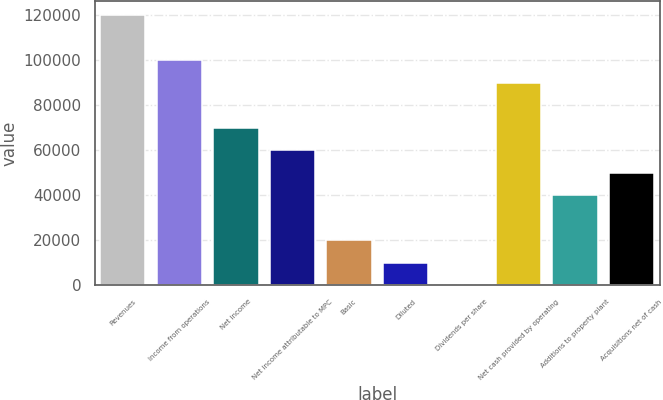Convert chart. <chart><loc_0><loc_0><loc_500><loc_500><bar_chart><fcel>Revenues<fcel>Income from operations<fcel>Net income<fcel>Net income attributable to MPC<fcel>Basic<fcel>Diluted<fcel>Dividends per share<fcel>Net cash provided by operating<fcel>Additions to property plant<fcel>Acquisitions net of cash<nl><fcel>120192<fcel>100160<fcel>70112.2<fcel>60096.3<fcel>20032.6<fcel>10016.7<fcel>0.77<fcel>90144.1<fcel>40064.4<fcel>50080.4<nl></chart> 